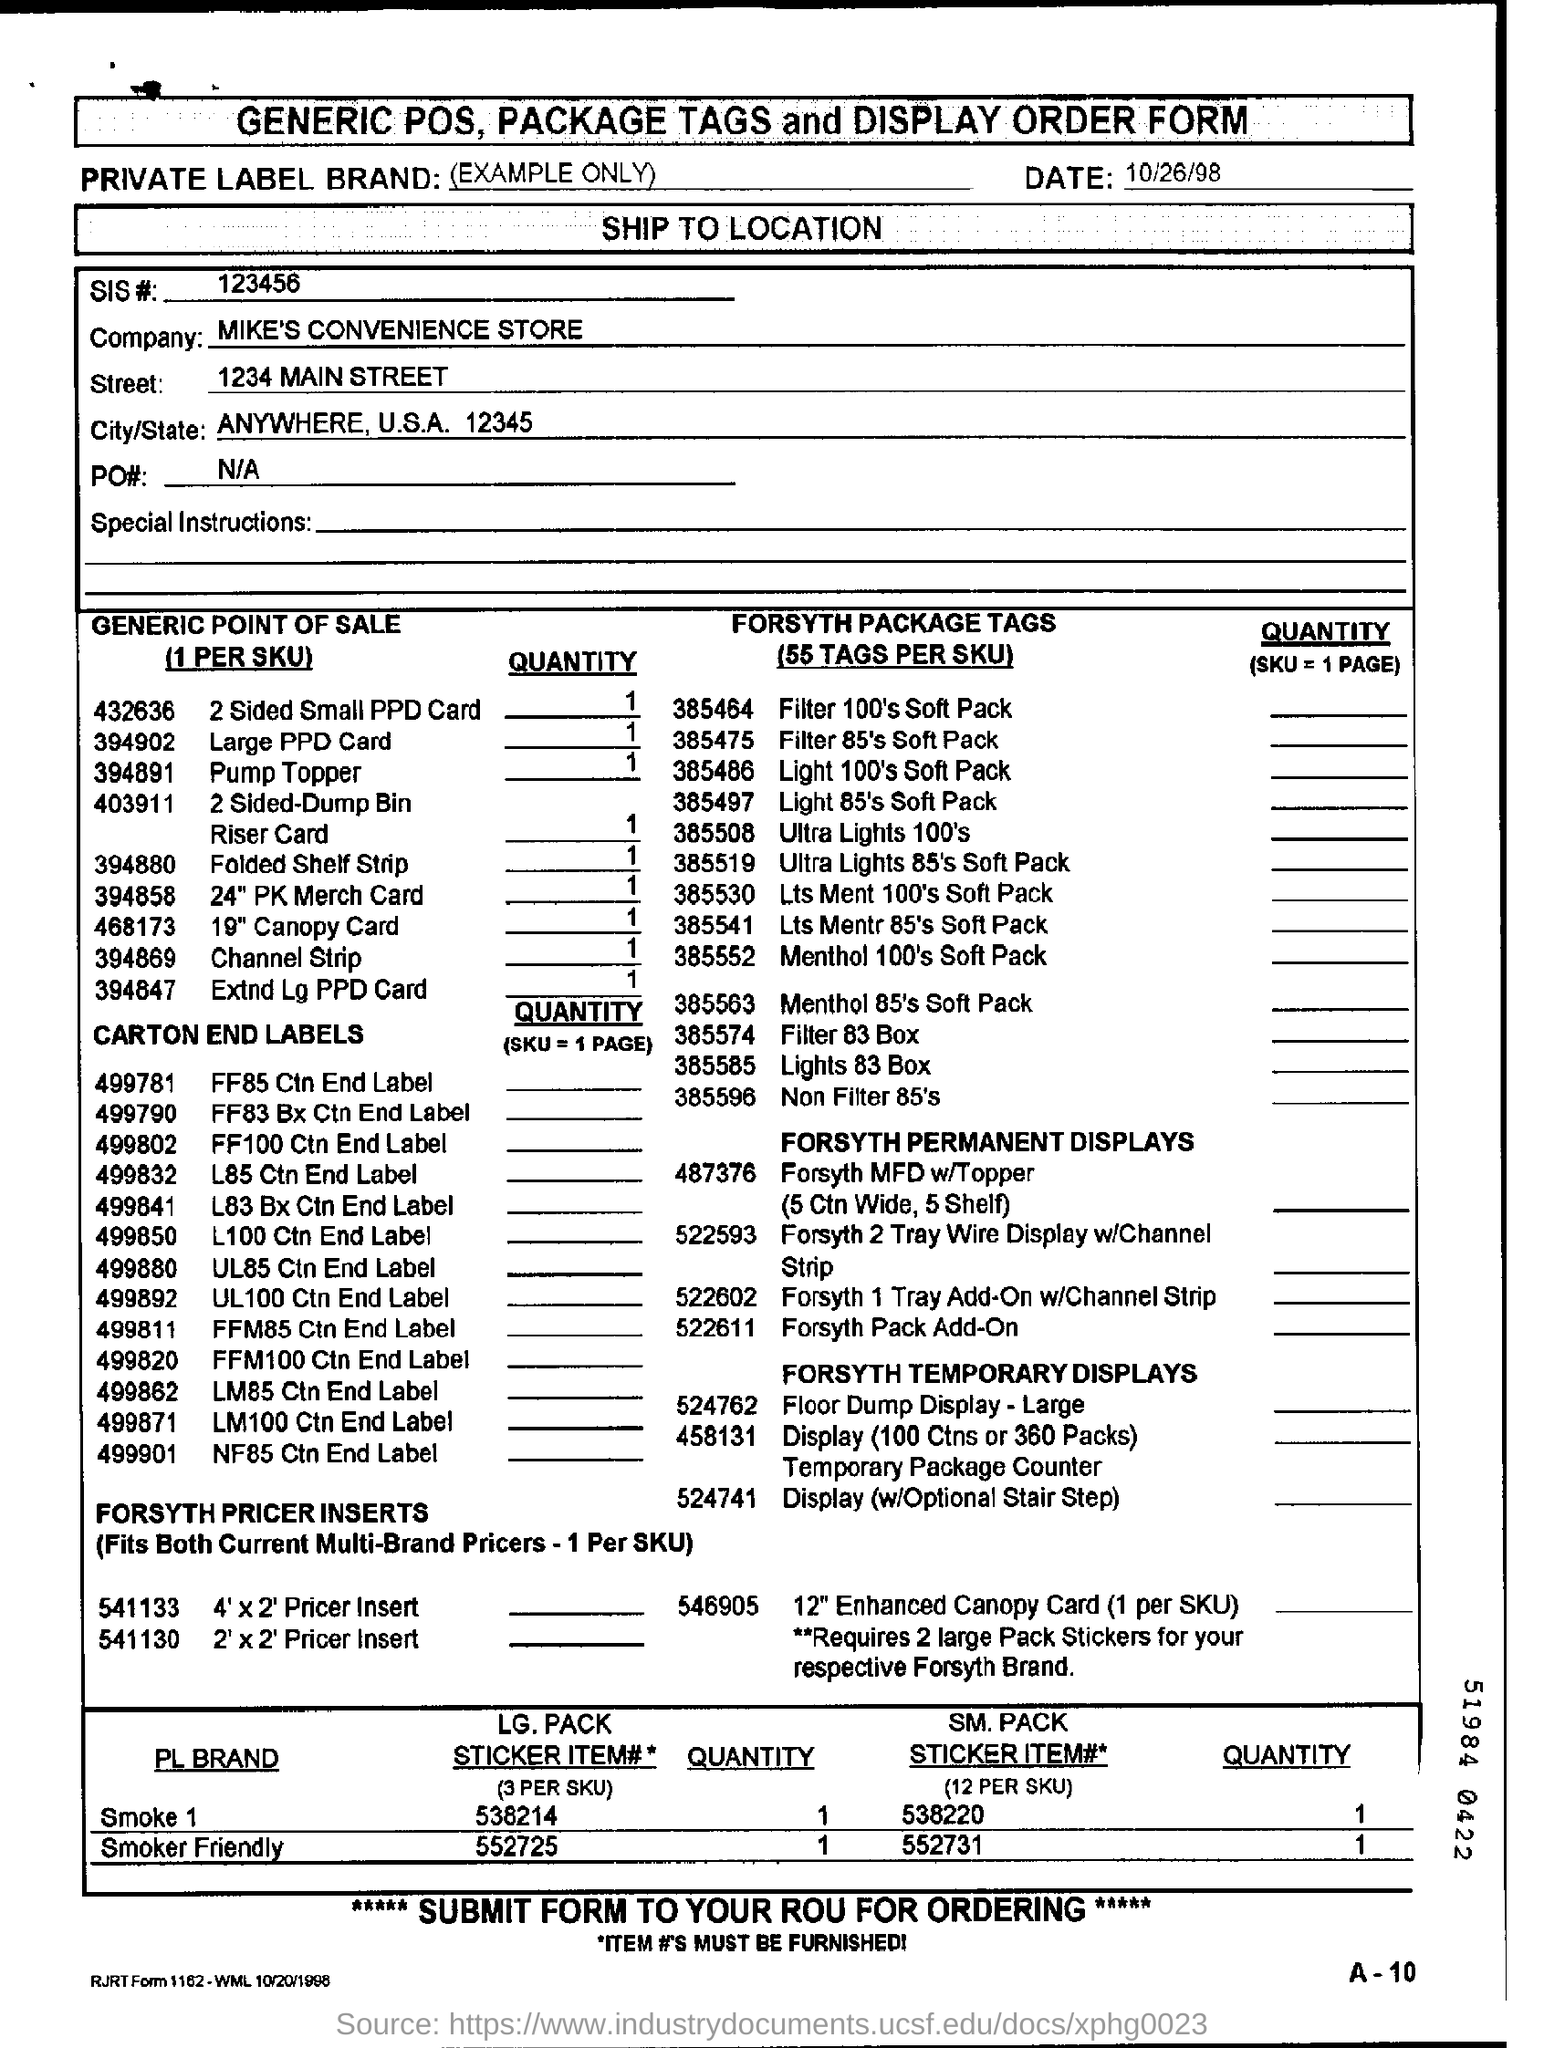Indicate a few pertinent items in this graphic. The SIS number is 123456... MIKE'S CONVENIENCE STORE is a company that operates a retail establishment that offers a variety of goods and services, including groceries, snacks, and household items. The date on the form is 10/26/98. 